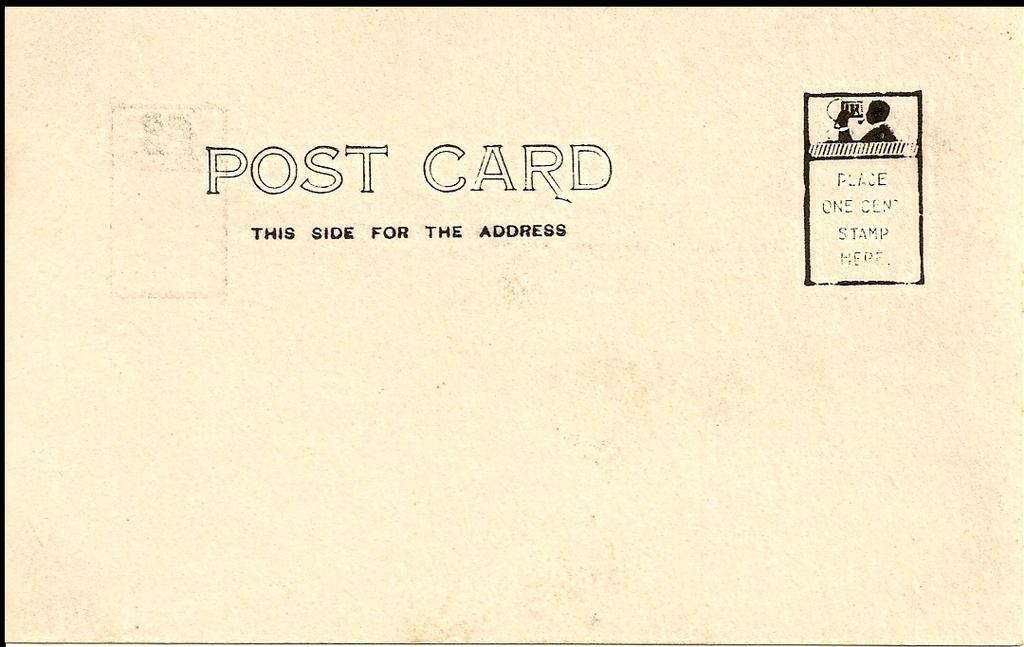Is the side shown for the address or not?
Provide a short and direct response. Yes. What kind of card is this?
Provide a succinct answer. Post card. 